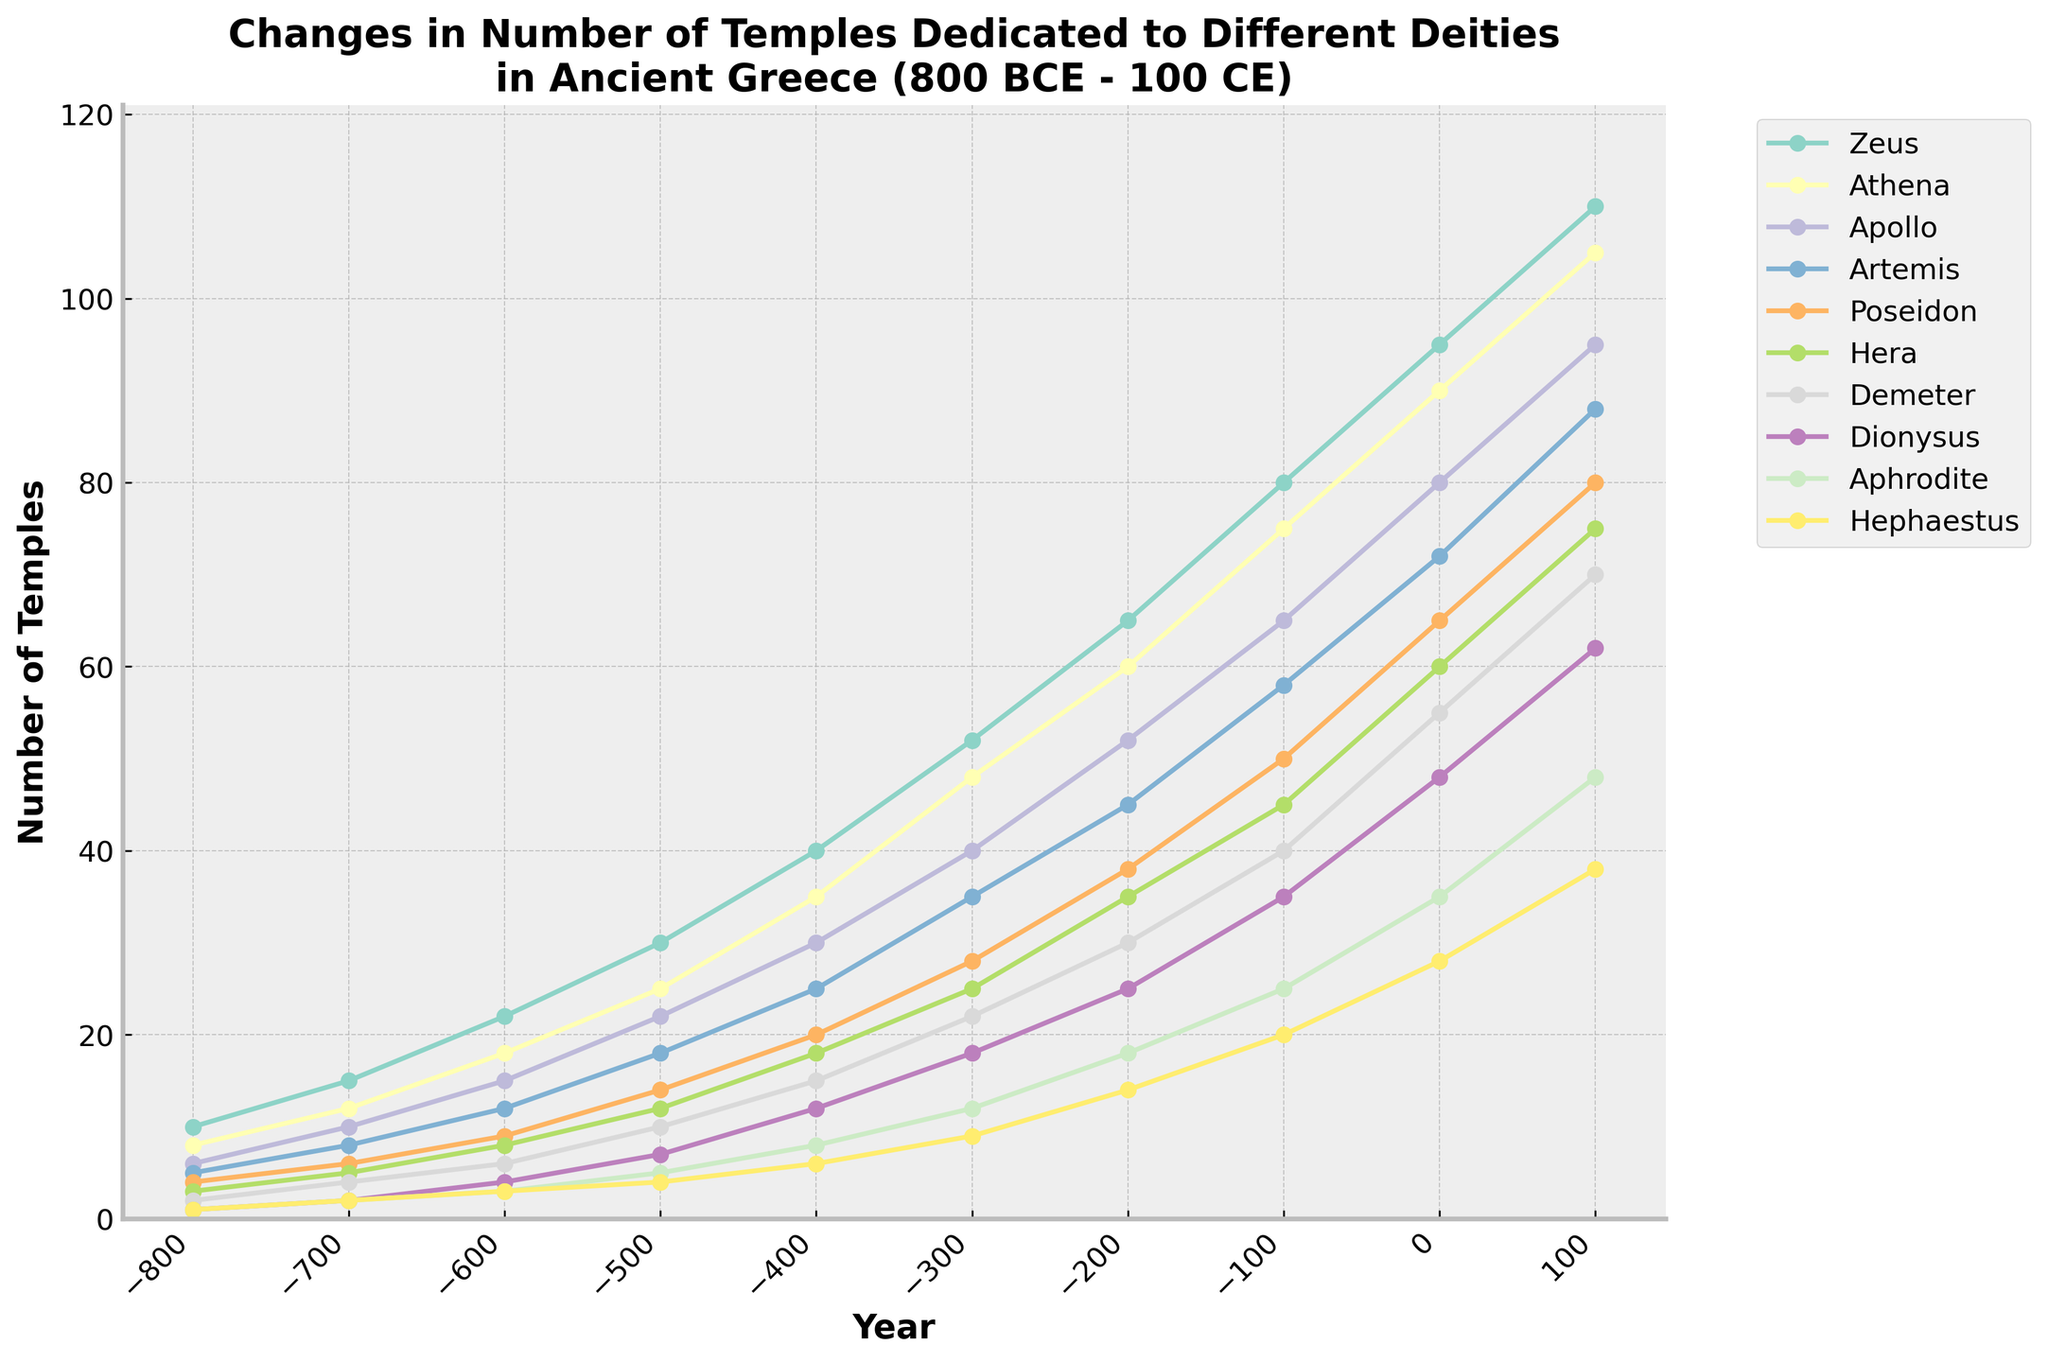What deity had the largest increase in the number of temples from 800 BCE to 100 CE? Begin by referencing the starting point for each deity at 800 BCE (the values in the first row of data). Then, check the number of temples for the same deities at 100 CE (the values in the last row of data). The deity with the largest numerical difference between 100 CE and 800 BCE will have had the largest increase. For example, Zeus has an increase from 10 to 110 temples, equaling a total increase of 100 temples.
Answer: Zeus Between 500 BCE and 0 CE, which deity saw the most significant percentage growth in the number of temples? Calculate the percentage increase for each deity from 500 BCE to 0 CE. The formula for percentage increase is [(value at 0 CE - value at 500 BCE) / value at 500 BCE] * 100. Compare the calculated percentages and identify the highest one. For instance, for Zeus: [(95 - 30) / 30] * 100 = 216.67%.
Answer: Zeus In which time period (century) did Athena see the most considerable rise in the number of temples? Review the data for Athena, focusing on the changes between consecutive centuries (like -800 to -700, -700 to -600, etc.). Calculate the numerical increase or decrease for each period. Identify the period with the largest numerical difference. For example, from -600 (18 temples) to -500 (25 temples), the increase is 25 - 18 = 7 temples.
Answer: -100 BCE to 0 CE Compare the number of temples dedicated to Demeter and Dionysus in 200 BCE. Which deity had more, and by how many? Look at the specific data points for Demeter and Dionysus in 200 BCE. Demeter had 30 temples, and Dionysus had 25 temples. Subtract the smaller number from the larger number to find the difference. Thus, Demeter had 30 - 25 = 5 more temples than Dionysus.
Answer: Demeter had 5 more temples Among the given deities, which one had the least number of temples in 0 CE? Check the data values for each deity listed at 0 CE. Observe which deity has the smallest number. For example, at 0 CE, Hephaestus has 28 temples, and the rest have more than 28 temples.
Answer: Hephaestus What was the total number of temples for all deities combined in 600 BCE? Sum up the number of temples for all deities at 600 BCE. The values are Zeus (22), Athena (18), Apollo (15), Artemis (12), Poseidon (9), Hera (8), Demeter (6), Dionysus (4), Aphrodite (3), and Hephaestus (3). The total is 22 + 18 + 15 + 12 + 9 + 8 + 6 + 4 + 3 + 3 = 100.
Answer: 100 By looking at the chart, which deity consistently had the second-highest number of temples from 800 BCE to 100 CE? Track down the patterns for each deity across all the given years in the chart. Identify the deity who continuously ranks second to another deity in terms of the number of temples. Observing this pattern, Athena typically follows Zeus, making her the consistent second-highest number holder.
Answer: Athena 